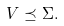<formula> <loc_0><loc_0><loc_500><loc_500>V \preceq \Sigma .</formula> 